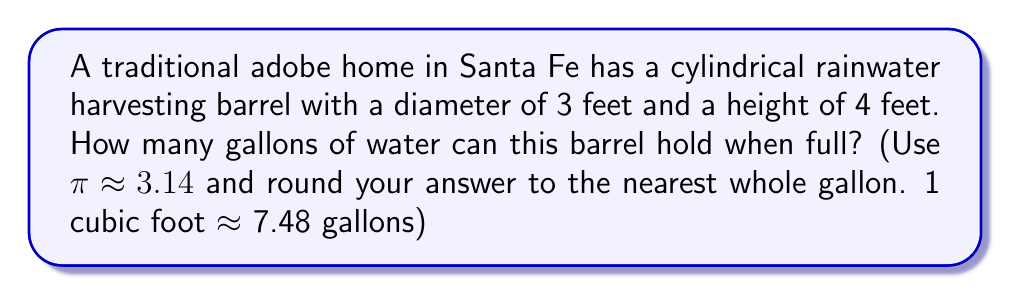Teach me how to tackle this problem. Let's approach this step-by-step:

1) First, we need to calculate the volume of the cylindrical barrel in cubic feet.
   The formula for the volume of a cylinder is:
   
   $$V = \pi r^2 h$$
   
   where $r$ is the radius and $h$ is the height.

2) We're given the diameter (3 feet), so the radius is half of that:
   $r = 3/2 = 1.5$ feet

3) Now we can plug in our values:
   
   $$V = 3.14 \cdot (1.5 \text{ ft})^2 \cdot 4 \text{ ft}$$

4) Let's calculate:
   
   $$V = 3.14 \cdot 2.25 \text{ ft}^2 \cdot 4 \text{ ft} = 28.26 \text{ ft}^3$$

5) Now we need to convert cubic feet to gallons:
   
   $$28.26 \text{ ft}^3 \cdot 7.48 \text{ gallons/ft}^3 = 211.39 \text{ gallons}$$

6) Rounding to the nearest whole gallon:
   
   211 gallons

[asy]
import geometry;

size(200);
real r = 3;
real h = 4;

path p = (0,0)--(0,h)::(r,h)--(r,0)--cycle;
revolution c = revolution(p,Z);

draw(surface(c),paleblue+opacity(0.5));
draw(c,blue);

label("3 ft",(r/2,0),S);
label("4 ft",(r,-h/2),E);

[/asy]
Answer: 211 gallons 